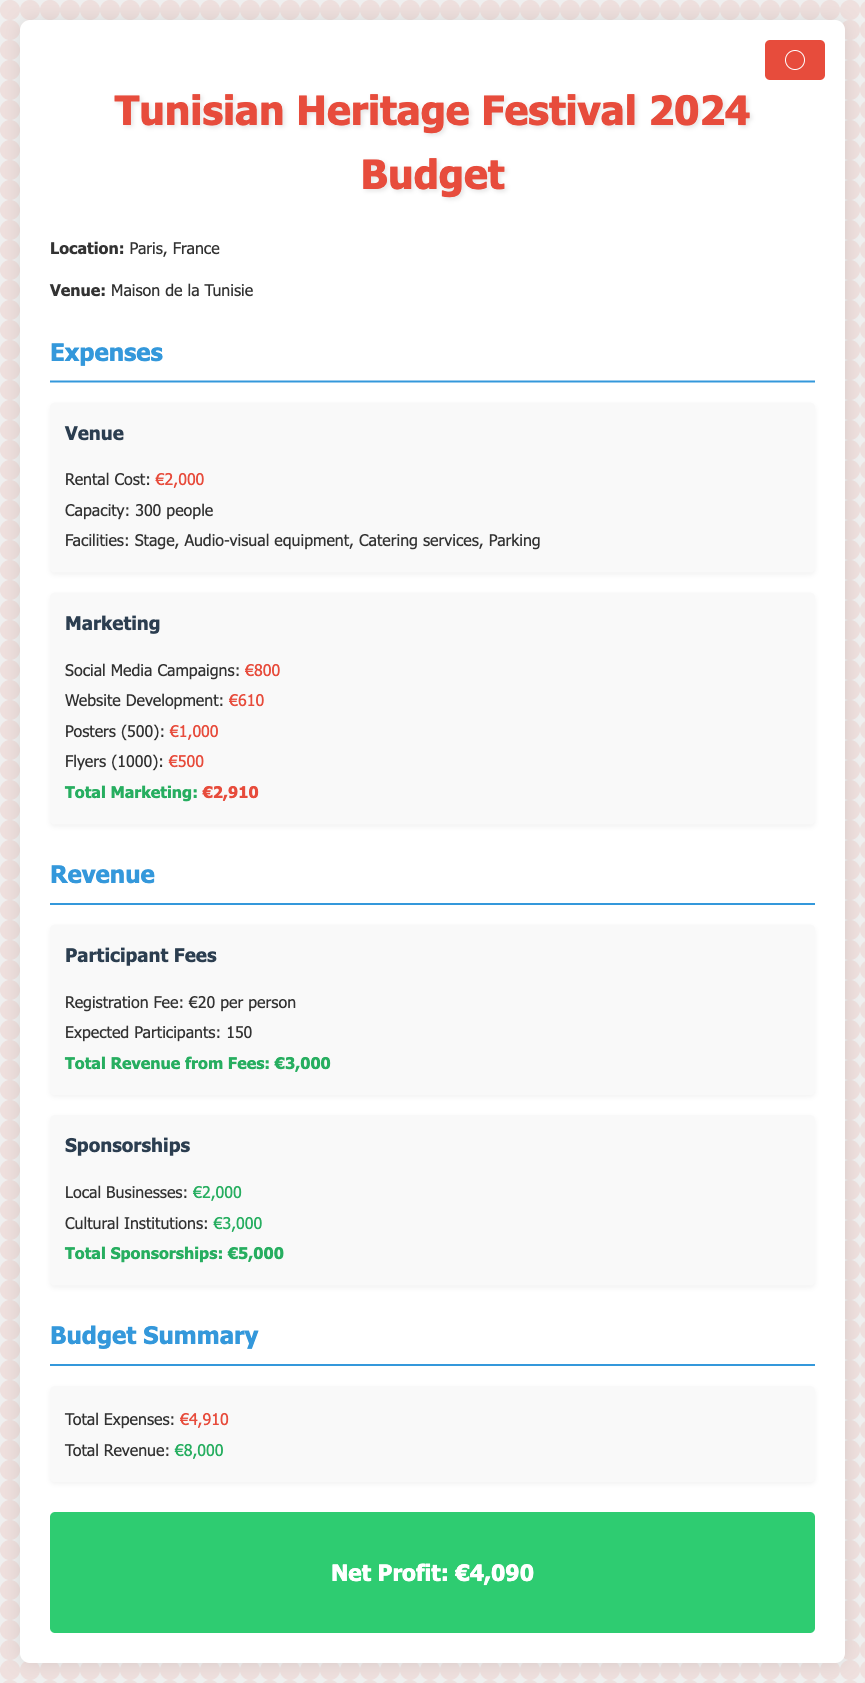What is the location of the festival? The document states that the festival is located in Paris, France.
Answer: Paris, France What is the rental cost for the venue? The rental cost mentioned for the venue is provided in the expenses section.
Answer: €2,000 What is the total expense for marketing? The total marketing cost is calculated by summing individual marketing expenses outlined in the document.
Answer: €2,910 How many expected participants are there? The expected number of participants is directly stated in the participant fees section of the document.
Answer: 150 What is the registration fee per person? The document specifies the registration fee for participants in the revenue section.
Answer: €20 What types of sponsorships are included in the budget? The document lists two types of sponsorships: local businesses and cultural institutions in the revenue section.
Answer: Local Businesses and Cultural Institutions What is the total revenue from participant fees? The total revenue from fees is calculated based on the registration fee and expected participants as described in the budget.
Answer: €3,000 What is the total revenue from sponsorships? The document provides the total revenue from two categories of sponsorships and sums them up in the revenue section.
Answer: €5,000 What is the net profit of the festival? The net profit is found by subtracting the total expenses from total revenue in the budget summary.
Answer: €4,090 